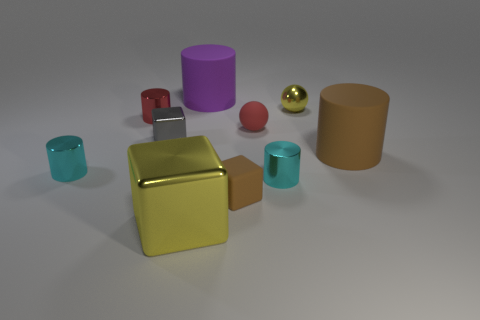Subtract all tiny cubes. How many cubes are left? 1 Subtract all balls. How many objects are left? 8 Subtract all cyan balls. How many cyan cylinders are left? 2 Subtract 0 cyan blocks. How many objects are left? 10 Subtract 1 blocks. How many blocks are left? 2 Subtract all green balls. Subtract all brown cylinders. How many balls are left? 2 Subtract all small red rubber spheres. Subtract all large metallic things. How many objects are left? 8 Add 1 small gray objects. How many small gray objects are left? 2 Add 1 shiny objects. How many shiny objects exist? 7 Subtract all yellow cubes. How many cubes are left? 2 